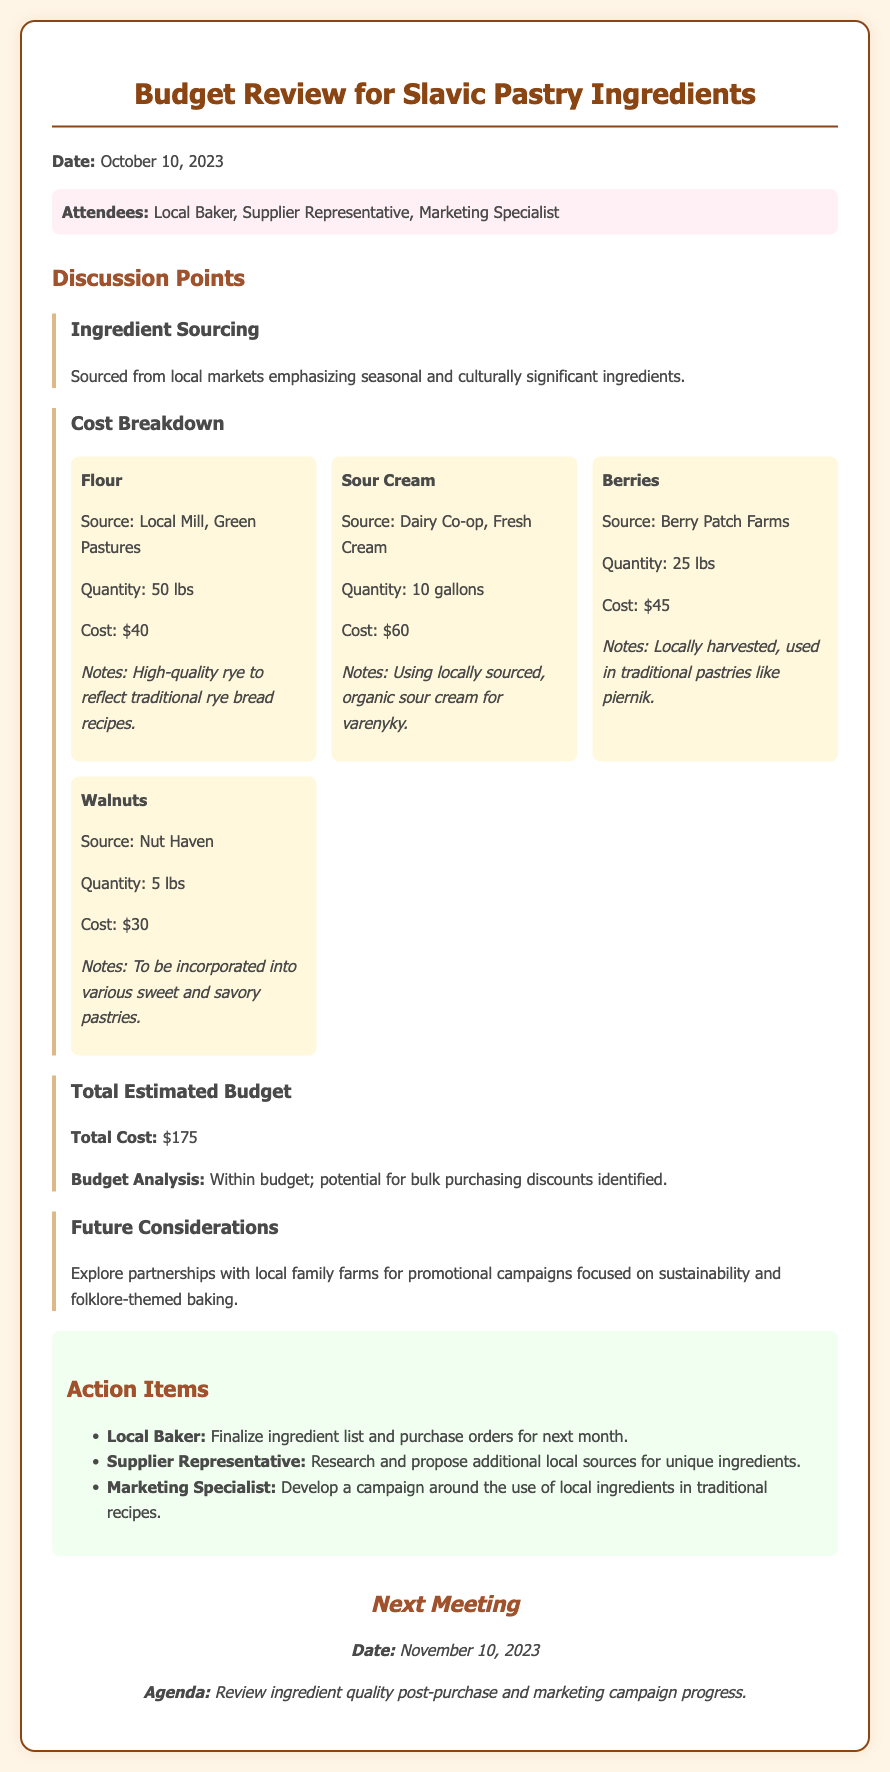What is the date of the meeting? The meeting took place on October 10, 2023, as stated in the document header.
Answer: October 10, 2023 Who are the attendees listed in the document? The document lists the attendees as Local Baker, Supplier Representative, and Marketing Specialist under the attendees' section.
Answer: Local Baker, Supplier Representative, Marketing Specialist What is the total cost for the ingredients? The total cost for the ingredients is mentioned under the total estimated budget section.
Answer: $175 What ingredient has the highest cost? The ingredient with the highest cost can be found by comparing the costs listed for each ingredient. Sour Cream costs $60 which is the highest among them.
Answer: Sour Cream What are the future considerations discussed in the meeting? Future considerations are outlined in a separate section that suggests exploring partnerships with local family farms.
Answer: Explore partnerships with local family farms What is the source for the flour mentioned in the document? The source for the flour is detailed under the cost breakdown for flour.
Answer: Local Mill, Green Pastures When is the next meeting scheduled? The next meeting date is provided at the end of the document as part of the next meeting section.
Answer: November 10, 2023 What is the quantity of berries sourced? The quantity of berries is specified in the cost breakdown section of the document.
Answer: 25 lbs What is a note related to walnuts mentioned in the document? Notes related to walnuts highlight their incorporation into various sweet and savory pastries as indicated under their cost breakdown.
Answer: Incorporated into various sweet and savory pastries 